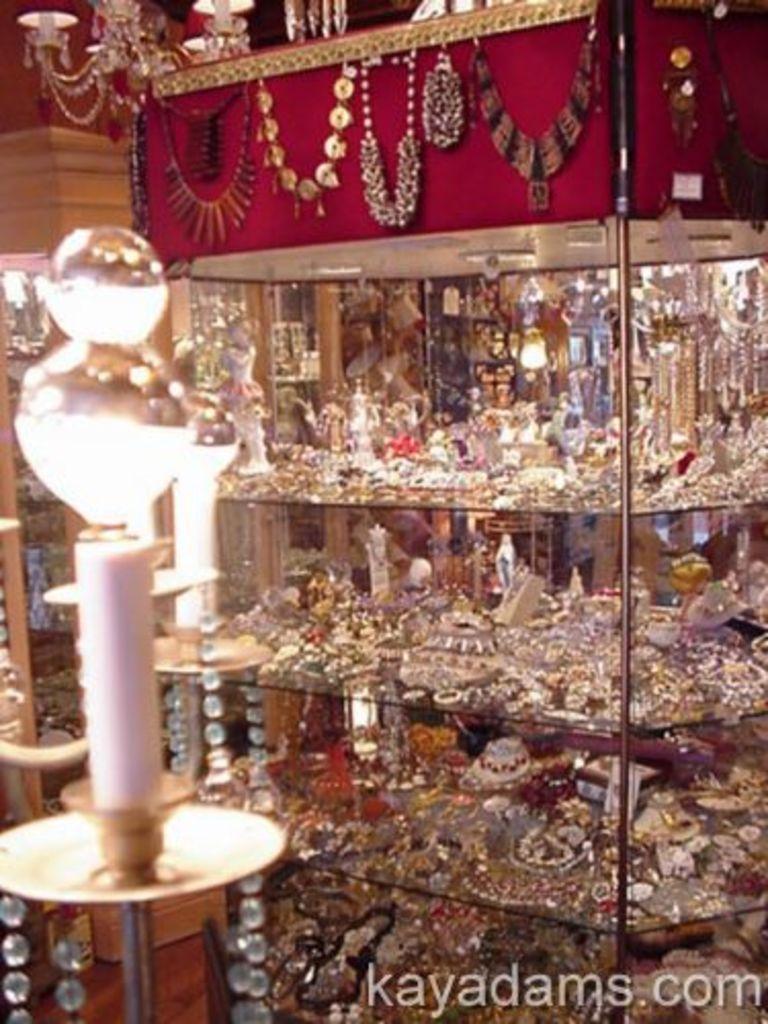Describe this image in one or two sentences. In this image I can see jewelries on these shelves. I can also see few more jewelries over here. Here I can see watermark. 